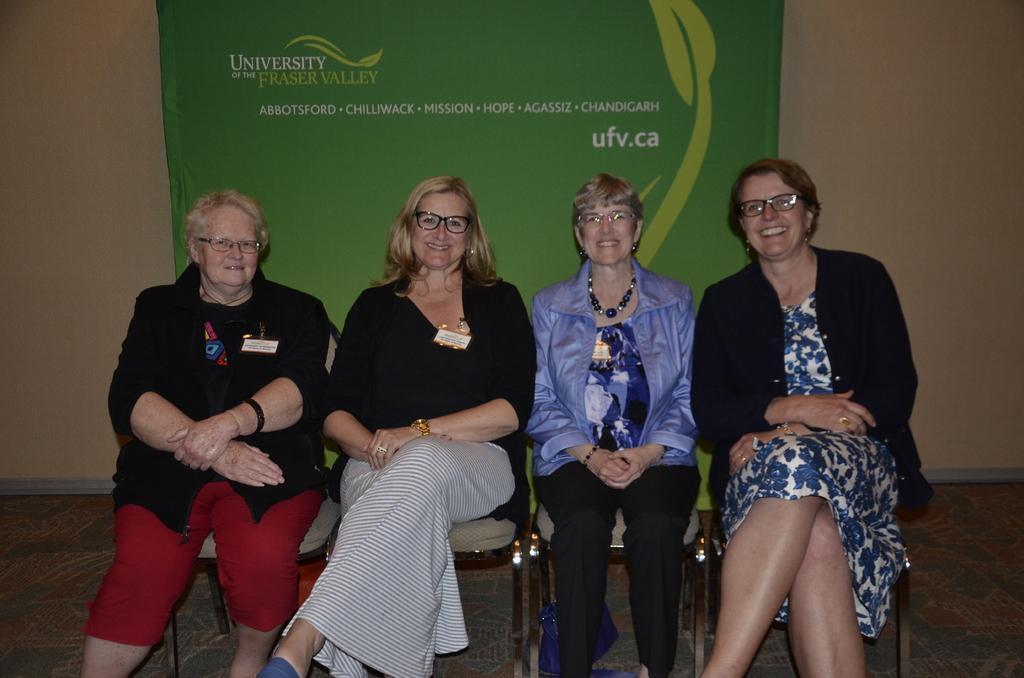How would you summarize this image in a sentence or two? In this image we can see four women wearing glasses and sitting on the chairs and smiling. In the background we can see the banner with text. We can also see the wall. Floor is also visible. 